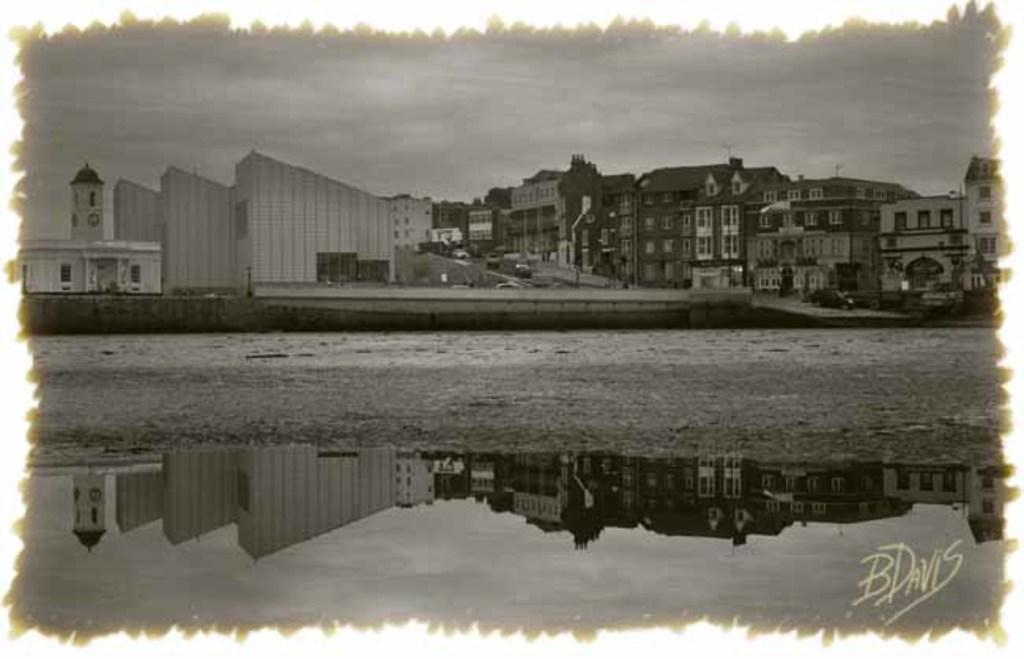What is the color scheme of the image? The image is in black and white. What can be seen on the ground in the image? There is a road in the image. What type of structures are present in the image? There are buildings in the image. What is visible above the ground in the image? The sky is visible in the image. What is a unique feature of the image? There is a reflection of the image in the water. Is there any additional information or branding present in the image? Yes, there is a watermark in the image. What is your dad doing in the image? There is no person, including your dad, present in the image. How many ducks can be seen swimming in the water in the image? There are no ducks present in the image; it features a reflection of the image in the water. 